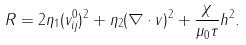Convert formula to latex. <formula><loc_0><loc_0><loc_500><loc_500>R = 2 \eta _ { 1 } ( v _ { i j } ^ { 0 } ) ^ { 2 } + \eta _ { 2 } ( \nabla \cdot { v } ) ^ { 2 } + \frac { \chi } { \mu _ { 0 } \tau } h ^ { 2 } .</formula> 